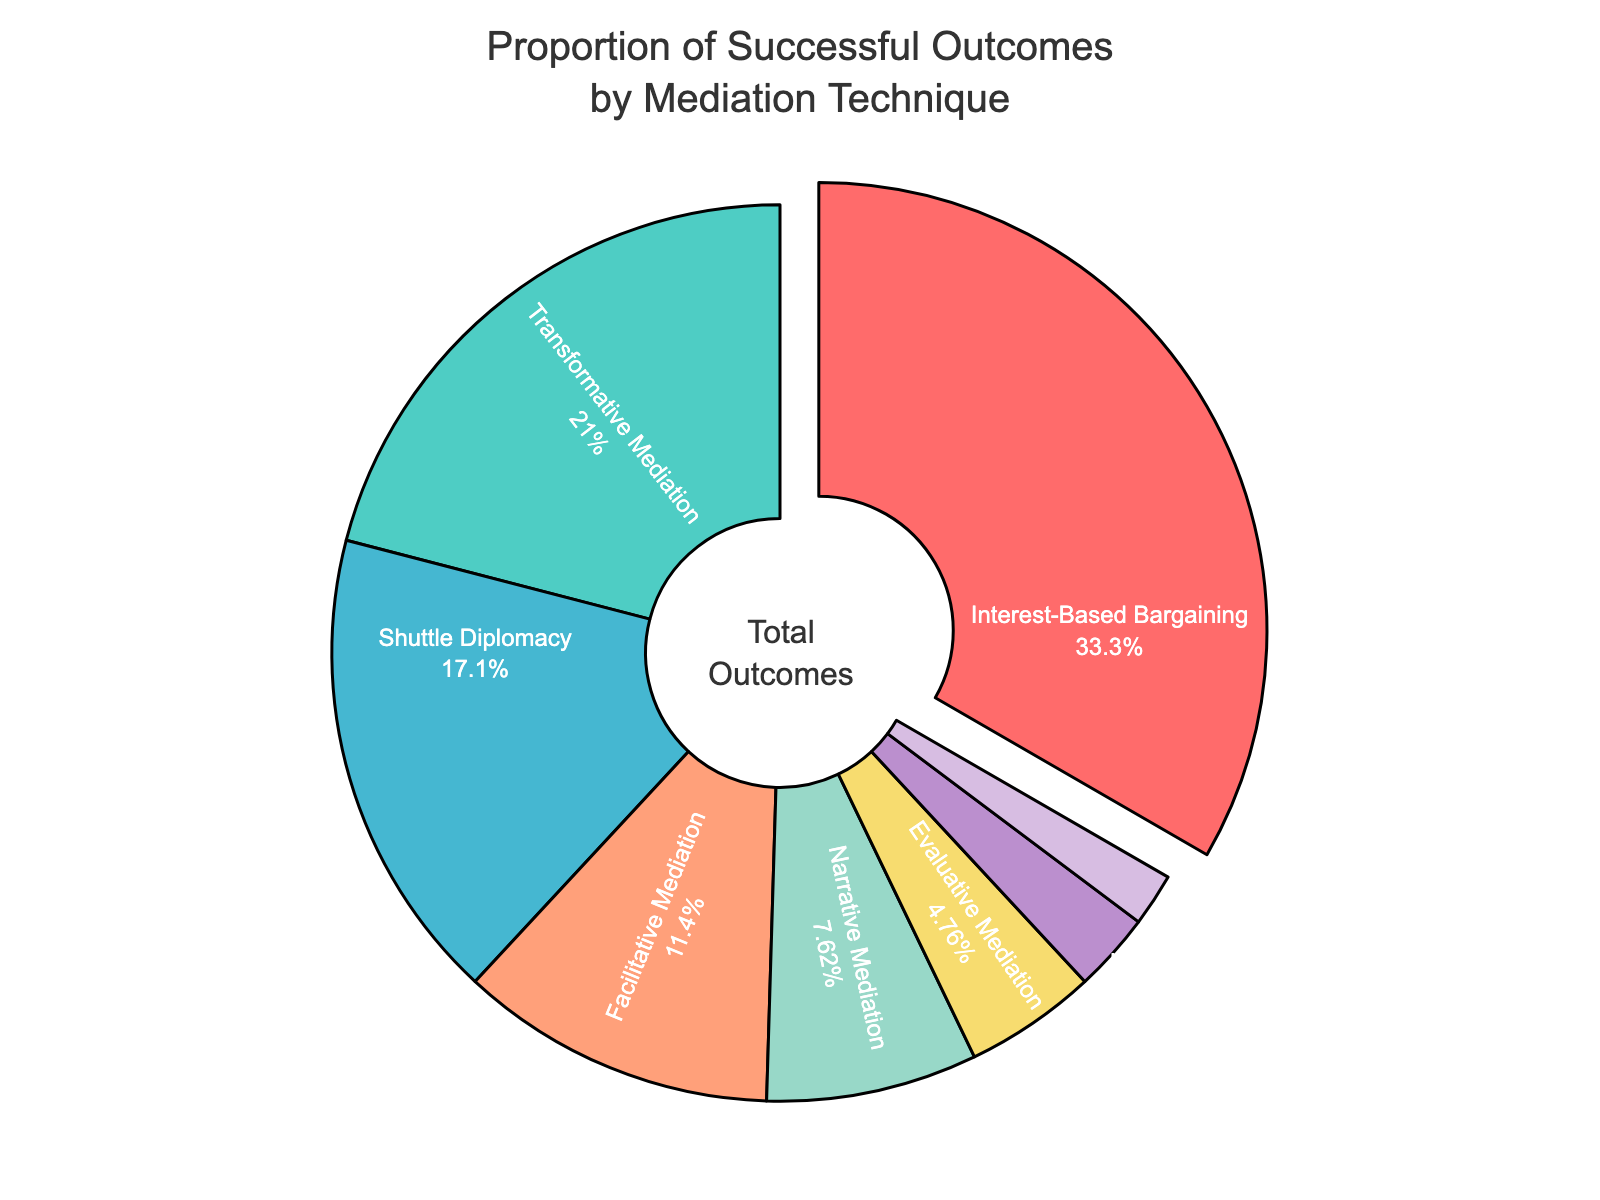What is the proportion of successful outcomes achieved through Interest-Based Bargaining? Interest-Based Bargaining has a segment where it shows both the technique name and the percentage. The percentage labeled on the figure for Interest-Based Bargaining is 35%.
Answer: 35% Which two techniques combined contribute to less than 10% of the successful outcomes? The pie chart shows the techniques and their respective percentages. Evaluative Mediation and Med-Arb have 5% and 2% respectively. Adding these together: 5% + 2% = 7%, which is less than 10%.
Answer: Evaluative Mediation and Med-Arb How does the proportion of successful outcomes achieved through Shuttle Diplomacy compare to that of Transformative Mediation? Shuttle Diplomacy has a segment that shows 18%, and Transformative Mediation has a segment that shows 22%. Therefore, Shuttle Diplomacy's proportion is less than Transformative Mediation's.
Answer: Less than Which technique has the smallest proportion of successful outcomes? The smallest proportion is indicated by the smallest segment in the pie chart, which shows 2% for Med-Arb.
Answer: Med-Arb Assuming each segment in the pie chart represents a distinct color, which color is used to represent Narrative Mediation? By looking at the color coded to the segment labeled "Narrative Mediation" which shows 8%, the corresponding color can be identified.
Answer: The specific color shown in the pie chart for the 8% segment If we combine the percentages for Facilitative Mediation and Shuttle Diplomacy, what is the proportion? The pie chart shows 12% for Facilitative Mediation and 18% for Shuttle Diplomacy. Adding these together: 12% + 18% = 30%.
Answer: 30% By how many percentage points is the proportion of successful outcomes from Interest-Based Bargaining greater than the next highest technique? Interest-Based Bargaining is 35%, and the next highest is Transformative Mediation at 22%. Calculating the difference: 35% - 22% = 13%.
Answer: 13% Which technique is represented by a segment pulled out from the center of the pie chart? The pie chart visually pulls out the segment labeled "Interest-Based Bargaining" from the center, highlighting it.
Answer: Interest-Based Bargaining What is the total percentage of outcomes for techniques with a proportion of less than 5% each? The figure shows Evaluative Mediation at 5%, Conciliation at 3%, and Med-Arb at 2%. Adding these together: 3% + 2% = 5%.
Answer: 5% How many techniques contribute to more than 10% of the successful outcomes? By inspecting the pie chart, four segments have percentages greater than 10%: Interest-Based Bargaining (35%), Transformative Mediation (22%), Shuttle Diplomacy (18%), and Facilitative Mediation (12%).
Answer: Four 